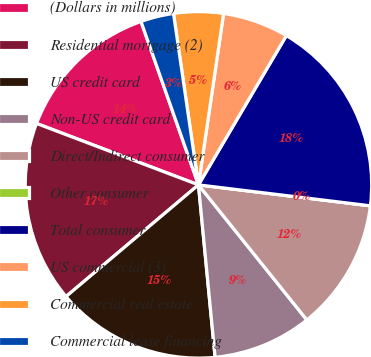<chart> <loc_0><loc_0><loc_500><loc_500><pie_chart><fcel>(Dollars in millions)<fcel>Residential mortgage (2)<fcel>US credit card<fcel>Non-US credit card<fcel>Direct/Indirect consumer<fcel>Other consumer<fcel>Total consumer<fcel>US commercial (3)<fcel>Commercial real estate<fcel>Commercial lease financing<nl><fcel>13.85%<fcel>16.92%<fcel>15.38%<fcel>9.23%<fcel>12.31%<fcel>0.0%<fcel>18.46%<fcel>6.15%<fcel>4.62%<fcel>3.08%<nl></chart> 